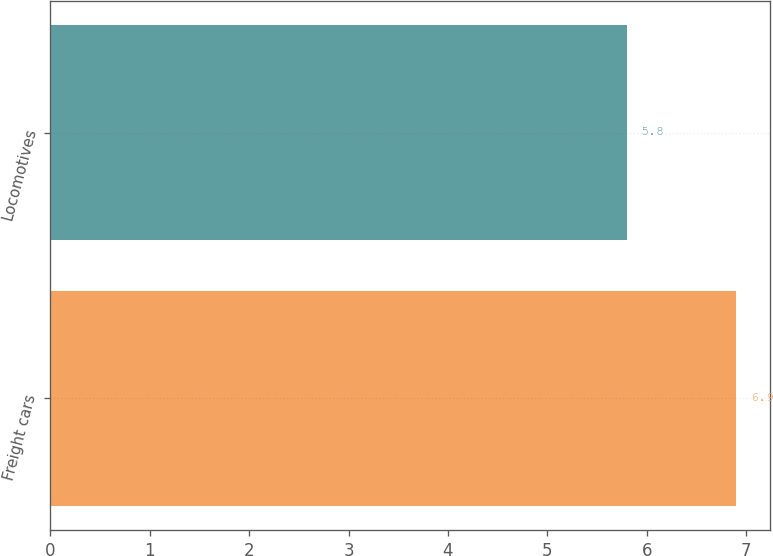<chart> <loc_0><loc_0><loc_500><loc_500><bar_chart><fcel>Freight cars<fcel>Locomotives<nl><fcel>6.9<fcel>5.8<nl></chart> 